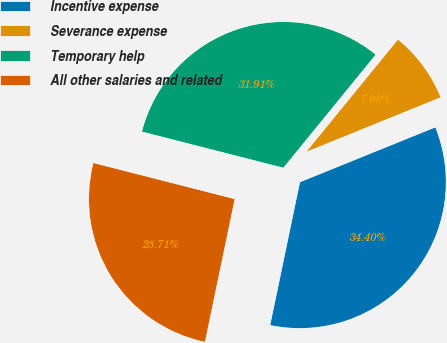Convert chart. <chart><loc_0><loc_0><loc_500><loc_500><pie_chart><fcel>Incentive expense<fcel>Severance expense<fcel>Temporary help<fcel>All other salaries and related<nl><fcel>34.4%<fcel>7.98%<fcel>31.91%<fcel>25.71%<nl></chart> 